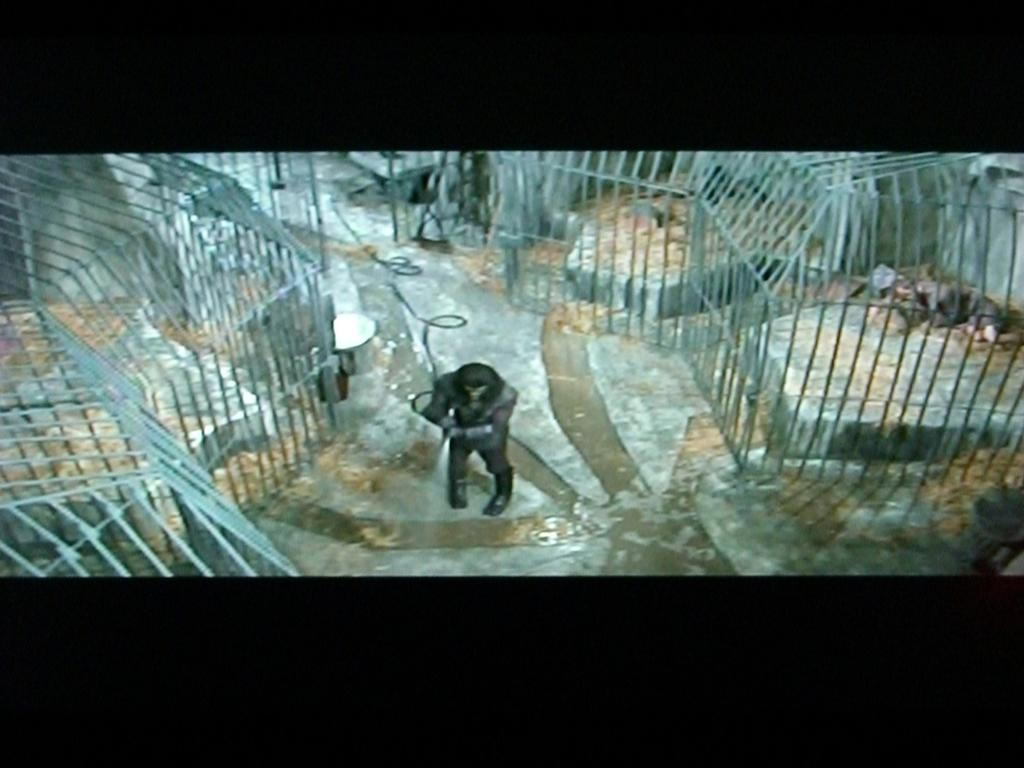What is the main subject of the image? There is a man standing in the image. What can be seen to the right of the man? There are animals in a cage to the right of the man. What is the surface on which the man and the cage are standing? There is a floor visible at the bottom of the image. What language is the man speaking in the image? There is no indication of the man speaking in the image, nor is there any information about the language he might be speaking. 